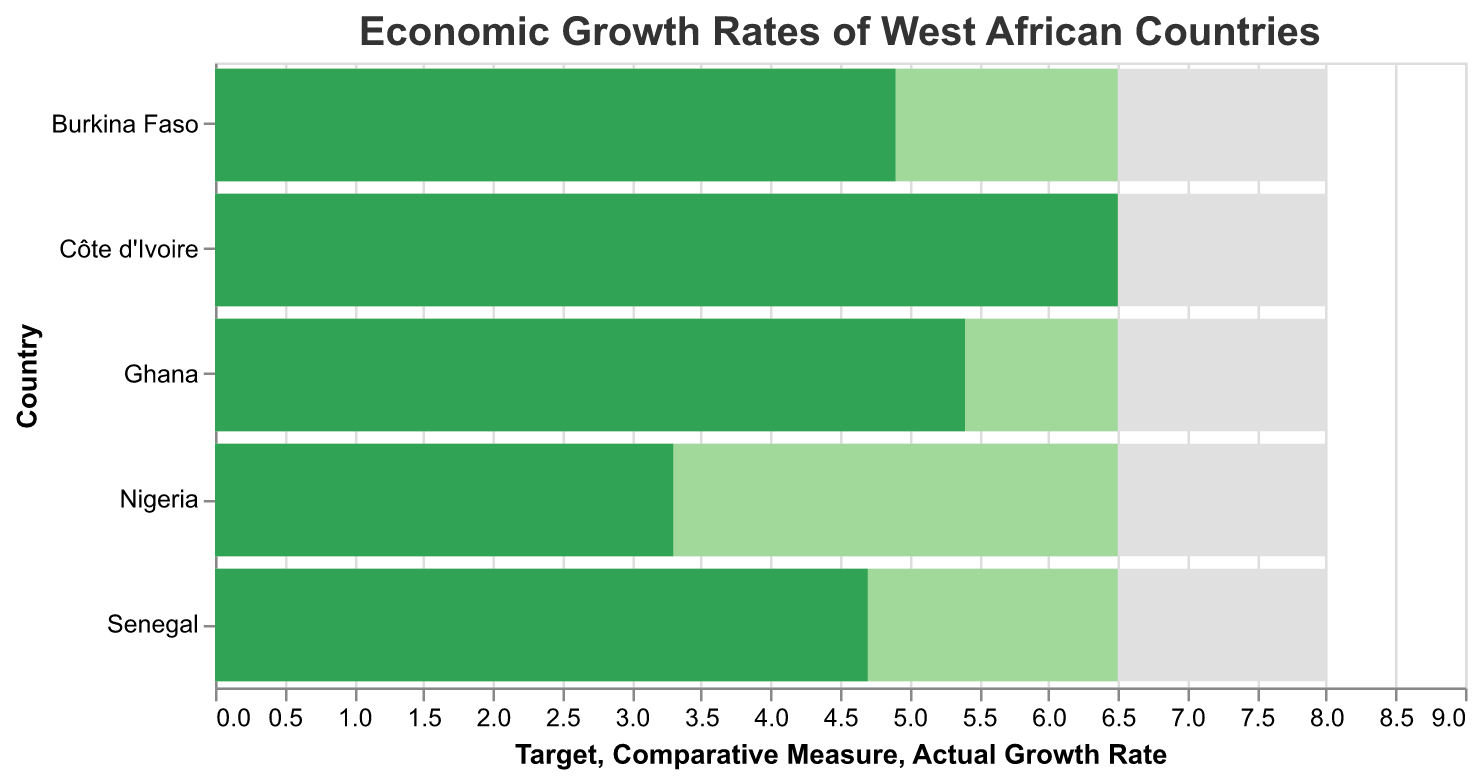What's the title of the figure? The title of the figure is a descriptive element positioned at the top. It provides a summary of what the figure represents. By looking at the title, you can understand the main subject matter of the chart.
Answer: Economic Growth Rates of West African Countries Which country has the highest actual growth rate? To find the country with the highest actual growth rate, compare the values associated with each country in the "Actual Growth Rate" category and identify the maximum. Côte d'Ivoire has an actual growth rate of 6.5, which is the highest among all listed countries.
Answer: Côte d'Ivoire What is Ghana's target growth rate? The target growth rate for Ghana is listed under the "Target" column. By referring directly to the row for Ghana and examining this column, the target is found.
Answer: 8.0 Which country has the lowest actual growth rate and what is it? To determine the country with the lowest actual growth rate, compare the actual growth rates of all the countries. Nigeria has the lowest actual growth rate at 3.3.
Answer: Nigeria at 3.3 How does Ghana's actual growth rate compare to the average growth rate? By examining Ghana's "Actual Growth Rate" of 5.4 and comparing it to the consistent "Comparative Measure" of 6.5 for all countries, we see Ghana's actual growth rate is lower than the average growth rate.
Answer: Lower By how much does Côte d'Ivoire's actual growth rate exceed Nigeria's actual growth rate? Look at the figures for both Côte d'Ivoire (6.5) and Nigeria (3.3), and calculate the difference between them: 6.5 - 3.3 = 3.2.
Answer: 3.2 Which countries have an actual growth rate below the comparative measure? By comparing the "Actual Growth Rate" of each country with the "Comparative Measure" of 6.5, identify the countries with rates less than 6.5. These countries are Ghana (5.4), Nigeria (3.3), Senegal (4.7), and Burkina Faso (4.9).
Answer: Ghana, Nigeria, Senegal, Burkina Faso Is there any country whose actual growth rate matches the target? Compare the "Actual Growth Rate" of each country to the "Target" of 8.0. None of the countries have an actual growth rate that matches the target.
Answer: No Which countries have an actual growth rate above 5.0? By reviewing the "Actual Growth Rate" for each country, identify those that have rates above 5.0. The countries are Ghana (5.4) and Côte d'Ivoire (6.5).
Answer: Ghana, Côte d'Ivoire 